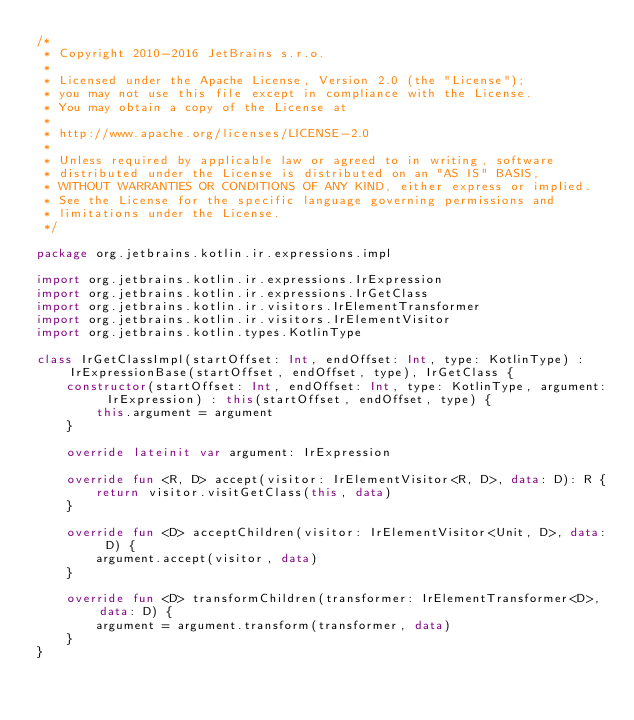<code> <loc_0><loc_0><loc_500><loc_500><_Kotlin_>/*
 * Copyright 2010-2016 JetBrains s.r.o.
 *
 * Licensed under the Apache License, Version 2.0 (the "License");
 * you may not use this file except in compliance with the License.
 * You may obtain a copy of the License at
 *
 * http://www.apache.org/licenses/LICENSE-2.0
 *
 * Unless required by applicable law or agreed to in writing, software
 * distributed under the License is distributed on an "AS IS" BASIS,
 * WITHOUT WARRANTIES OR CONDITIONS OF ANY KIND, either express or implied.
 * See the License for the specific language governing permissions and
 * limitations under the License.
 */

package org.jetbrains.kotlin.ir.expressions.impl

import org.jetbrains.kotlin.ir.expressions.IrExpression
import org.jetbrains.kotlin.ir.expressions.IrGetClass
import org.jetbrains.kotlin.ir.visitors.IrElementTransformer
import org.jetbrains.kotlin.ir.visitors.IrElementVisitor
import org.jetbrains.kotlin.types.KotlinType

class IrGetClassImpl(startOffset: Int, endOffset: Int, type: KotlinType) : IrExpressionBase(startOffset, endOffset, type), IrGetClass {
    constructor(startOffset: Int, endOffset: Int, type: KotlinType, argument: IrExpression) : this(startOffset, endOffset, type) {
        this.argument = argument
    }

    override lateinit var argument: IrExpression

    override fun <R, D> accept(visitor: IrElementVisitor<R, D>, data: D): R {
        return visitor.visitGetClass(this, data)
    }

    override fun <D> acceptChildren(visitor: IrElementVisitor<Unit, D>, data: D) {
        argument.accept(visitor, data)
    }

    override fun <D> transformChildren(transformer: IrElementTransformer<D>, data: D) {
        argument = argument.transform(transformer, data)
    }
}</code> 